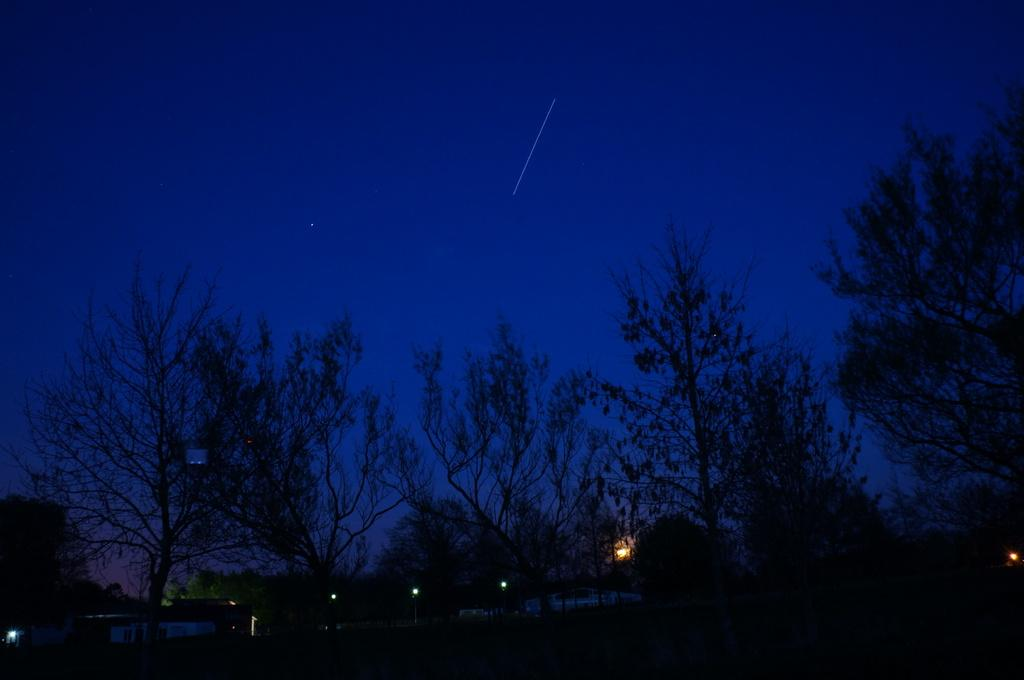What type of vegetation can be seen in the image? There are trees in the image. What else is present in the image besides the trees? There are lights in the image. Can you see a garden with a fireman blowing out candles in the image? No, there is no garden, fireman, or candles present in the image. 